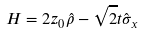Convert formula to latex. <formula><loc_0><loc_0><loc_500><loc_500>H = 2 z _ { 0 } \hat { \rho } - \sqrt { 2 } t \hat { \sigma } _ { x }</formula> 